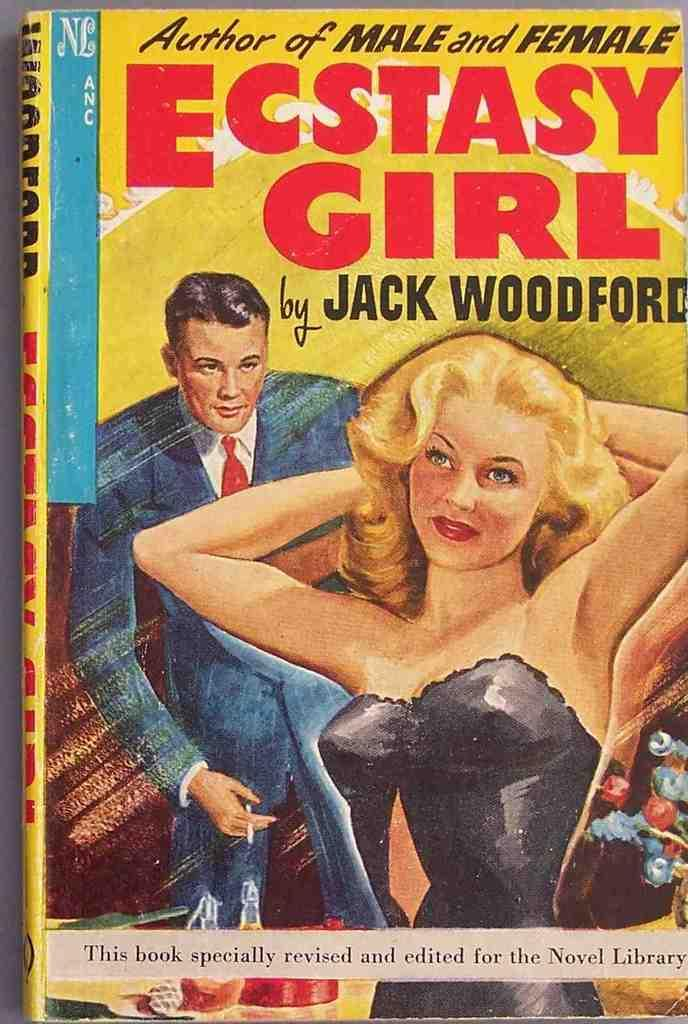Provide a one-sentence caption for the provided image. A cover of an older book written by Jack Woodford, portraying a woman and a man. 